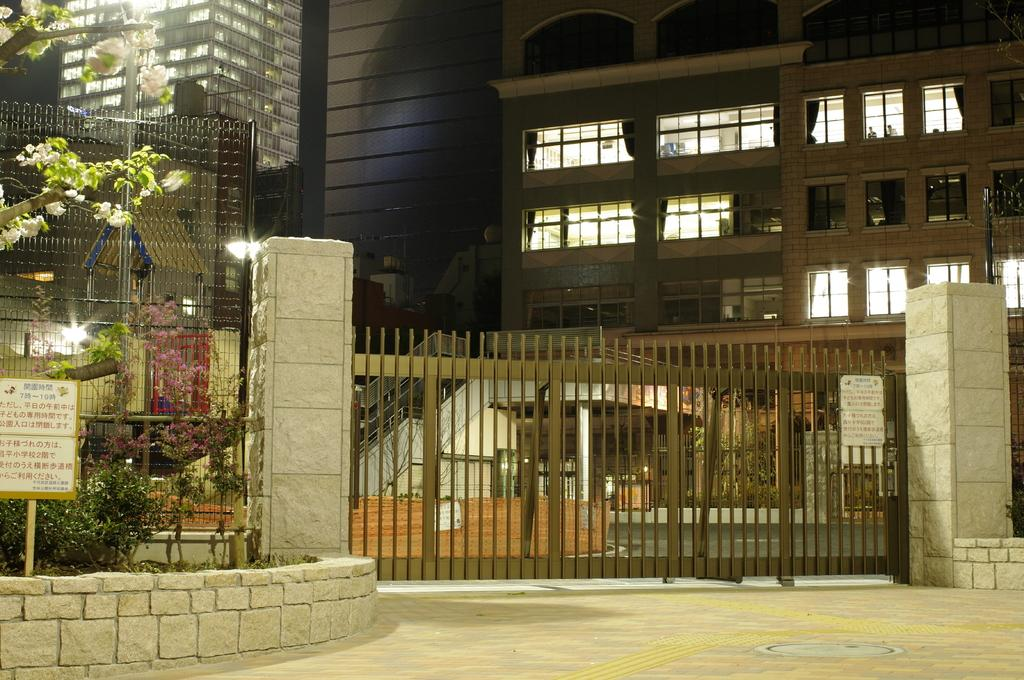What type of structures can be seen in the image? There are buildings in the image. What type of barrier is present in the image? There is fencing in the image. What type of vegetation is visible in the image? There are trees in the image. What type of entrance is present in the image? There is a gate to a wall in the image. What type of meal is being served in the image? There is no meal present in the image. What type of tooth is visible in the image? There are no teeth visible in the image. 